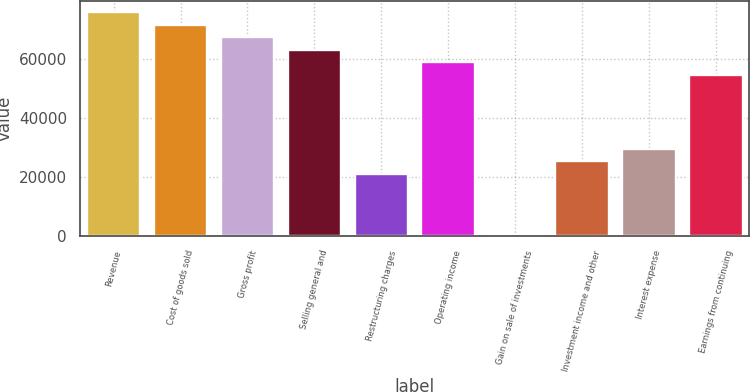Convert chart. <chart><loc_0><loc_0><loc_500><loc_500><bar_chart><fcel>Revenue<fcel>Cost of goods sold<fcel>Gross profit<fcel>Selling general and<fcel>Restructuring charges<fcel>Operating income<fcel>Gain on sale of investments<fcel>Investment income and other<fcel>Interest expense<fcel>Earnings from continuing<nl><fcel>75871<fcel>71656<fcel>67441<fcel>63226<fcel>21076<fcel>59011<fcel>1<fcel>25291<fcel>29506<fcel>54796<nl></chart> 